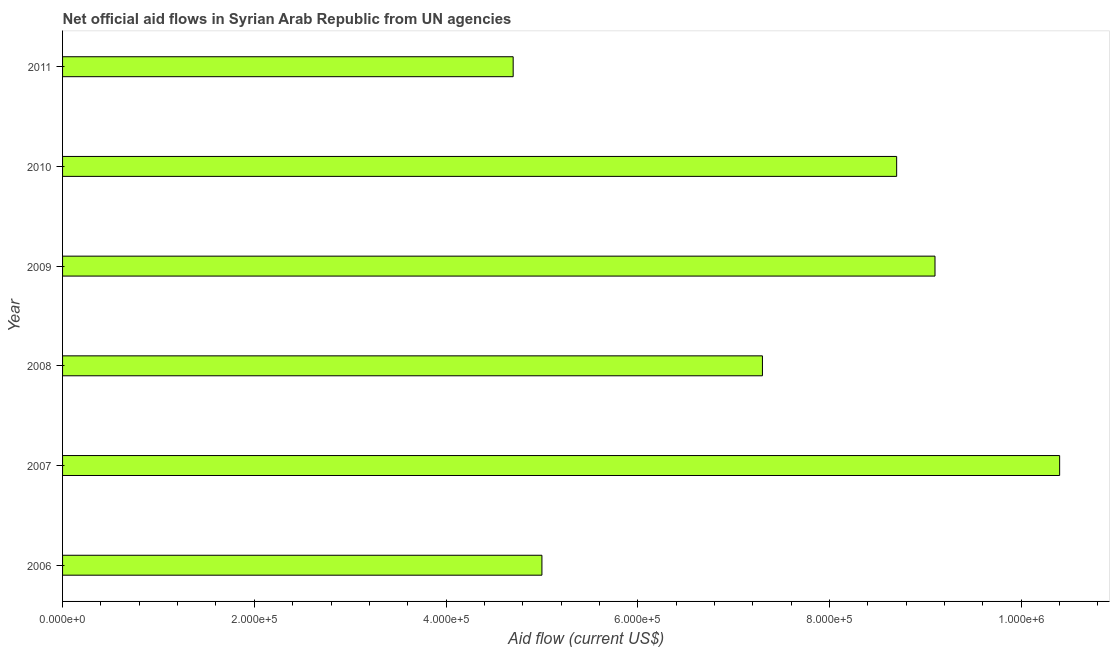Does the graph contain any zero values?
Keep it short and to the point. No. What is the title of the graph?
Offer a terse response. Net official aid flows in Syrian Arab Republic from UN agencies. What is the label or title of the Y-axis?
Offer a terse response. Year. What is the net official flows from un agencies in 2009?
Your response must be concise. 9.10e+05. Across all years, what is the maximum net official flows from un agencies?
Your answer should be very brief. 1.04e+06. Across all years, what is the minimum net official flows from un agencies?
Provide a succinct answer. 4.70e+05. What is the sum of the net official flows from un agencies?
Make the answer very short. 4.52e+06. What is the difference between the net official flows from un agencies in 2007 and 2010?
Keep it short and to the point. 1.70e+05. What is the average net official flows from un agencies per year?
Provide a short and direct response. 7.53e+05. What is the median net official flows from un agencies?
Keep it short and to the point. 8.00e+05. What is the ratio of the net official flows from un agencies in 2007 to that in 2011?
Provide a succinct answer. 2.21. Is the net official flows from un agencies in 2006 less than that in 2008?
Give a very brief answer. Yes. What is the difference between the highest and the second highest net official flows from un agencies?
Offer a very short reply. 1.30e+05. Is the sum of the net official flows from un agencies in 2007 and 2011 greater than the maximum net official flows from un agencies across all years?
Offer a very short reply. Yes. What is the difference between the highest and the lowest net official flows from un agencies?
Keep it short and to the point. 5.70e+05. How many bars are there?
Your response must be concise. 6. Are all the bars in the graph horizontal?
Your response must be concise. Yes. How many years are there in the graph?
Give a very brief answer. 6. Are the values on the major ticks of X-axis written in scientific E-notation?
Your response must be concise. Yes. What is the Aid flow (current US$) in 2007?
Offer a terse response. 1.04e+06. What is the Aid flow (current US$) of 2008?
Make the answer very short. 7.30e+05. What is the Aid flow (current US$) in 2009?
Offer a terse response. 9.10e+05. What is the Aid flow (current US$) of 2010?
Offer a very short reply. 8.70e+05. What is the difference between the Aid flow (current US$) in 2006 and 2007?
Keep it short and to the point. -5.40e+05. What is the difference between the Aid flow (current US$) in 2006 and 2009?
Keep it short and to the point. -4.10e+05. What is the difference between the Aid flow (current US$) in 2006 and 2010?
Keep it short and to the point. -3.70e+05. What is the difference between the Aid flow (current US$) in 2006 and 2011?
Your answer should be compact. 3.00e+04. What is the difference between the Aid flow (current US$) in 2007 and 2011?
Your response must be concise. 5.70e+05. What is the difference between the Aid flow (current US$) in 2008 and 2009?
Keep it short and to the point. -1.80e+05. What is the difference between the Aid flow (current US$) in 2008 and 2011?
Your response must be concise. 2.60e+05. What is the difference between the Aid flow (current US$) in 2009 and 2010?
Your answer should be very brief. 4.00e+04. What is the difference between the Aid flow (current US$) in 2009 and 2011?
Offer a very short reply. 4.40e+05. What is the difference between the Aid flow (current US$) in 2010 and 2011?
Your answer should be very brief. 4.00e+05. What is the ratio of the Aid flow (current US$) in 2006 to that in 2007?
Make the answer very short. 0.48. What is the ratio of the Aid flow (current US$) in 2006 to that in 2008?
Make the answer very short. 0.69. What is the ratio of the Aid flow (current US$) in 2006 to that in 2009?
Offer a terse response. 0.55. What is the ratio of the Aid flow (current US$) in 2006 to that in 2010?
Your response must be concise. 0.57. What is the ratio of the Aid flow (current US$) in 2006 to that in 2011?
Ensure brevity in your answer.  1.06. What is the ratio of the Aid flow (current US$) in 2007 to that in 2008?
Your answer should be compact. 1.43. What is the ratio of the Aid flow (current US$) in 2007 to that in 2009?
Provide a short and direct response. 1.14. What is the ratio of the Aid flow (current US$) in 2007 to that in 2010?
Your answer should be very brief. 1.2. What is the ratio of the Aid flow (current US$) in 2007 to that in 2011?
Keep it short and to the point. 2.21. What is the ratio of the Aid flow (current US$) in 2008 to that in 2009?
Provide a succinct answer. 0.8. What is the ratio of the Aid flow (current US$) in 2008 to that in 2010?
Offer a terse response. 0.84. What is the ratio of the Aid flow (current US$) in 2008 to that in 2011?
Your response must be concise. 1.55. What is the ratio of the Aid flow (current US$) in 2009 to that in 2010?
Make the answer very short. 1.05. What is the ratio of the Aid flow (current US$) in 2009 to that in 2011?
Provide a succinct answer. 1.94. What is the ratio of the Aid flow (current US$) in 2010 to that in 2011?
Make the answer very short. 1.85. 